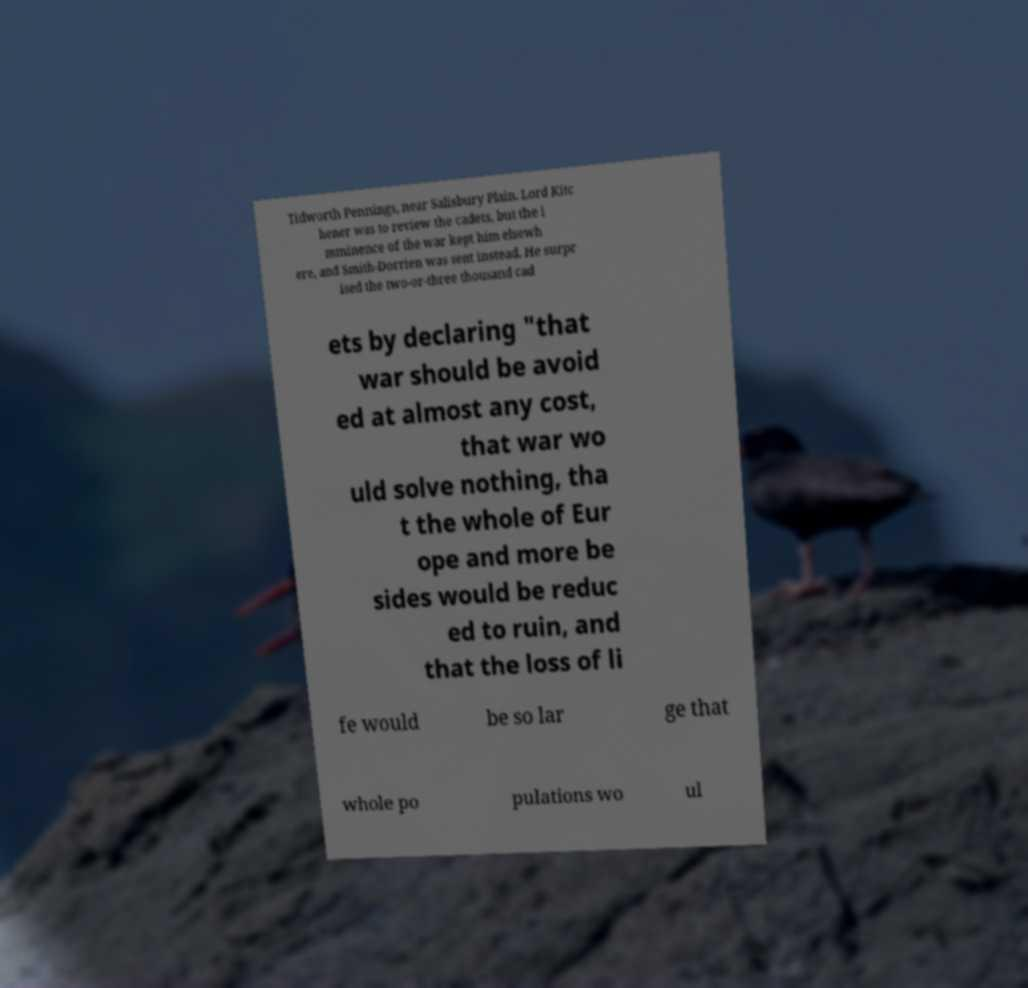Please identify and transcribe the text found in this image. Tidworth Pennings, near Salisbury Plain. Lord Kitc hener was to review the cadets, but the i mminence of the war kept him elsewh ere, and Smith-Dorrien was sent instead. He surpr ised the two-or-three thousand cad ets by declaring "that war should be avoid ed at almost any cost, that war wo uld solve nothing, tha t the whole of Eur ope and more be sides would be reduc ed to ruin, and that the loss of li fe would be so lar ge that whole po pulations wo ul 